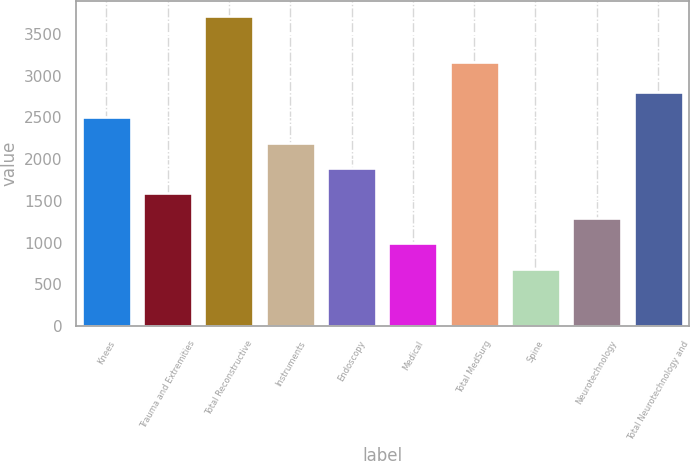Convert chart to OTSL. <chart><loc_0><loc_0><loc_500><loc_500><bar_chart><fcel>Knees<fcel>Trauma and Extremities<fcel>Total Reconstructive<fcel>Instruments<fcel>Endoscopy<fcel>Medical<fcel>Total MedSurg<fcel>Spine<fcel>Neurotechnology<fcel>Total Neurotechnology and<nl><fcel>2500.8<fcel>1593.9<fcel>3710<fcel>2198.5<fcel>1896.2<fcel>989.3<fcel>3160<fcel>687<fcel>1291.6<fcel>2803.1<nl></chart> 